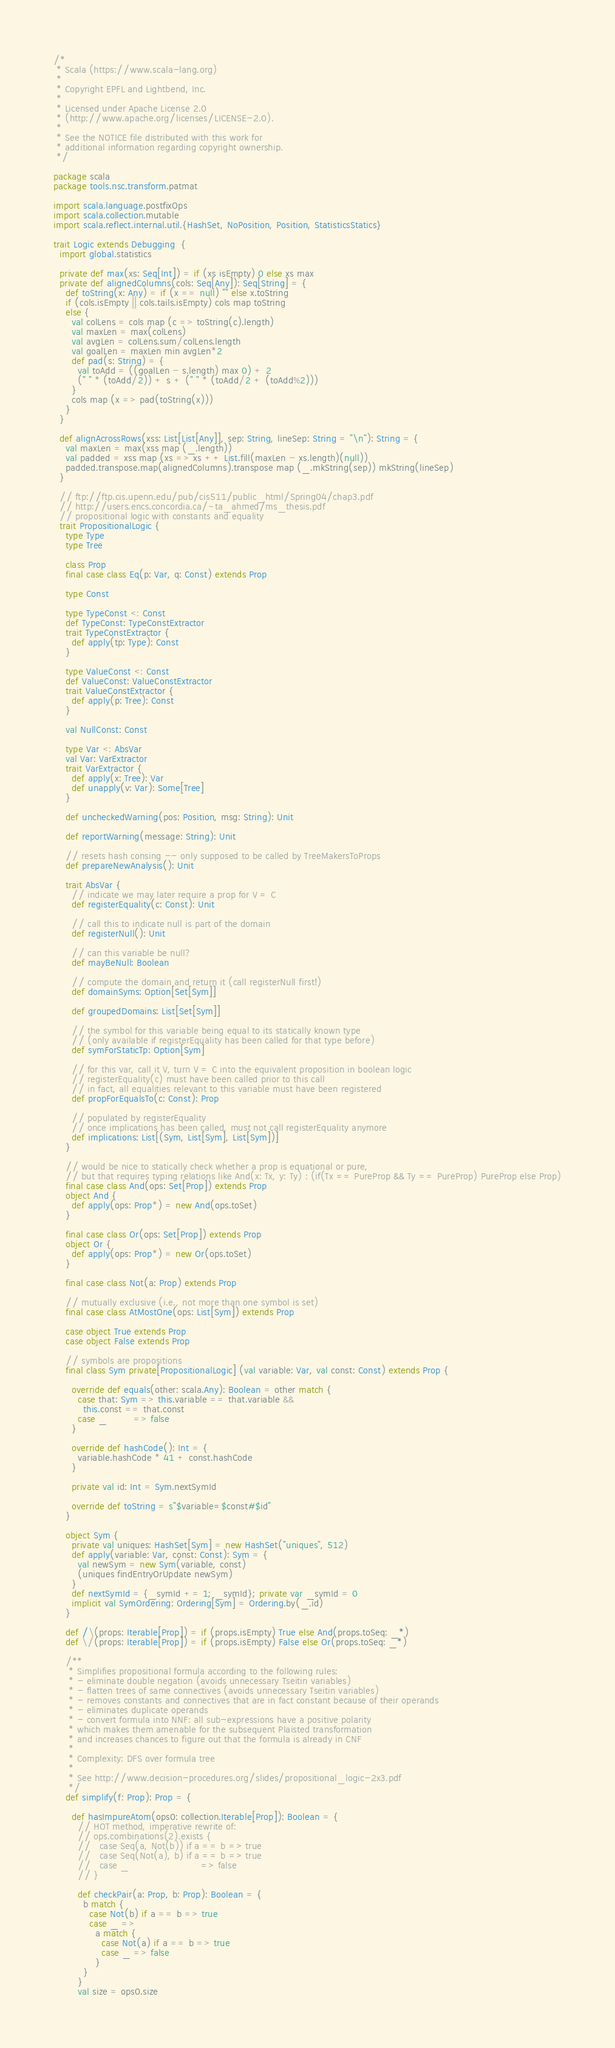<code> <loc_0><loc_0><loc_500><loc_500><_Scala_>/*
 * Scala (https://www.scala-lang.org)
 *
 * Copyright EPFL and Lightbend, Inc.
 *
 * Licensed under Apache License 2.0
 * (http://www.apache.org/licenses/LICENSE-2.0).
 *
 * See the NOTICE file distributed with this work for
 * additional information regarding copyright ownership.
 */

package scala
package tools.nsc.transform.patmat

import scala.language.postfixOps
import scala.collection.mutable
import scala.reflect.internal.util.{HashSet, NoPosition, Position, StatisticsStatics}

trait Logic extends Debugging  {
  import global.statistics

  private def max(xs: Seq[Int]) = if (xs isEmpty) 0 else xs max
  private def alignedColumns(cols: Seq[Any]): Seq[String] = {
    def toString(x: Any) = if (x == null) "" else x.toString
    if (cols.isEmpty || cols.tails.isEmpty) cols map toString
    else {
      val colLens = cols map (c => toString(c).length)
      val maxLen = max(colLens)
      val avgLen = colLens.sum/colLens.length
      val goalLen = maxLen min avgLen*2
      def pad(s: String) = {
        val toAdd = ((goalLen - s.length) max 0) + 2
        (" " * (toAdd/2)) + s + (" " * (toAdd/2 + (toAdd%2)))
      }
      cols map (x => pad(toString(x)))
    }
  }

  def alignAcrossRows(xss: List[List[Any]], sep: String, lineSep: String = "\n"): String = {
    val maxLen = max(xss map (_.length))
    val padded = xss map (xs => xs ++ List.fill(maxLen - xs.length)(null))
    padded.transpose.map(alignedColumns).transpose map (_.mkString(sep)) mkString(lineSep)
  }

  // ftp://ftp.cis.upenn.edu/pub/cis511/public_html/Spring04/chap3.pdf
  // http://users.encs.concordia.ca/~ta_ahmed/ms_thesis.pdf
  // propositional logic with constants and equality
  trait PropositionalLogic {
    type Type
    type Tree

    class Prop
    final case class Eq(p: Var, q: Const) extends Prop

    type Const

    type TypeConst <: Const
    def TypeConst: TypeConstExtractor
    trait TypeConstExtractor {
      def apply(tp: Type): Const
    }

    type ValueConst <: Const
    def ValueConst: ValueConstExtractor
    trait ValueConstExtractor {
      def apply(p: Tree): Const
    }

    val NullConst: Const

    type Var <: AbsVar
    val Var: VarExtractor
    trait VarExtractor {
      def apply(x: Tree): Var
      def unapply(v: Var): Some[Tree]
    }

    def uncheckedWarning(pos: Position, msg: String): Unit

    def reportWarning(message: String): Unit

    // resets hash consing -- only supposed to be called by TreeMakersToProps
    def prepareNewAnalysis(): Unit

    trait AbsVar {
      // indicate we may later require a prop for V = C
      def registerEquality(c: Const): Unit

      // call this to indicate null is part of the domain
      def registerNull(): Unit

      // can this variable be null?
      def mayBeNull: Boolean

      // compute the domain and return it (call registerNull first!)
      def domainSyms: Option[Set[Sym]]

      def groupedDomains: List[Set[Sym]]

      // the symbol for this variable being equal to its statically known type
      // (only available if registerEquality has been called for that type before)
      def symForStaticTp: Option[Sym]

      // for this var, call it V, turn V = C into the equivalent proposition in boolean logic
      // registerEquality(c) must have been called prior to this call
      // in fact, all equalities relevant to this variable must have been registered
      def propForEqualsTo(c: Const): Prop

      // populated by registerEquality
      // once implications has been called, must not call registerEquality anymore
      def implications: List[(Sym, List[Sym], List[Sym])]
    }

    // would be nice to statically check whether a prop is equational or pure,
    // but that requires typing relations like And(x: Tx, y: Ty) : (if(Tx == PureProp && Ty == PureProp) PureProp else Prop)
    final case class And(ops: Set[Prop]) extends Prop
    object And {
      def apply(ops: Prop*) = new And(ops.toSet)
    }

    final case class Or(ops: Set[Prop]) extends Prop
    object Or {
      def apply(ops: Prop*) = new Or(ops.toSet)
    }

    final case class Not(a: Prop) extends Prop

    // mutually exclusive (i.e., not more than one symbol is set)
    final case class AtMostOne(ops: List[Sym]) extends Prop

    case object True extends Prop
    case object False extends Prop

    // symbols are propositions
    final class Sym private[PropositionalLogic] (val variable: Var, val const: Const) extends Prop {

      override def equals(other: scala.Any): Boolean = other match {
        case that: Sym => this.variable == that.variable &&
          this.const == that.const
        case _         => false
      }

      override def hashCode(): Int = {
        variable.hashCode * 41 + const.hashCode
      }

      private val id: Int = Sym.nextSymId

      override def toString = s"$variable=$const#$id"
    }

    object Sym {
      private val uniques: HashSet[Sym] = new HashSet("uniques", 512)
      def apply(variable: Var, const: Const): Sym = {
        val newSym = new Sym(variable, const)
        (uniques findEntryOrUpdate newSym)
      }
      def nextSymId = {_symId += 1; _symId}; private var _symId = 0
      implicit val SymOrdering: Ordering[Sym] = Ordering.by(_.id)
    }

    def /\(props: Iterable[Prop]) = if (props.isEmpty) True else And(props.toSeq: _*)
    def \/(props: Iterable[Prop]) = if (props.isEmpty) False else Or(props.toSeq: _*)

    /**
     * Simplifies propositional formula according to the following rules:
     * - eliminate double negation (avoids unnecessary Tseitin variables)
     * - flatten trees of same connectives (avoids unnecessary Tseitin variables)
     * - removes constants and connectives that are in fact constant because of their operands
     * - eliminates duplicate operands
     * - convert formula into NNF: all sub-expressions have a positive polarity
     * which makes them amenable for the subsequent Plaisted transformation
     * and increases chances to figure out that the formula is already in CNF
     *
     * Complexity: DFS over formula tree
     *
     * See http://www.decision-procedures.org/slides/propositional_logic-2x3.pdf
     */
    def simplify(f: Prop): Prop = {

      def hasImpureAtom(ops0: collection.Iterable[Prop]): Boolean = {
        // HOT method, imperative rewrite of:
        // ops.combinations(2).exists {
        //   case Seq(a, Not(b)) if a == b => true
        //   case Seq(Not(a), b) if a == b => true
        //   case _                        => false
        // }

        def checkPair(a: Prop, b: Prop): Boolean = {
          b match {
            case Not(b) if a == b => true
            case _ =>
              a match {
                case Not(a) if a == b => true
                case _ => false
              }
          }
        }
        val size = ops0.size</code> 